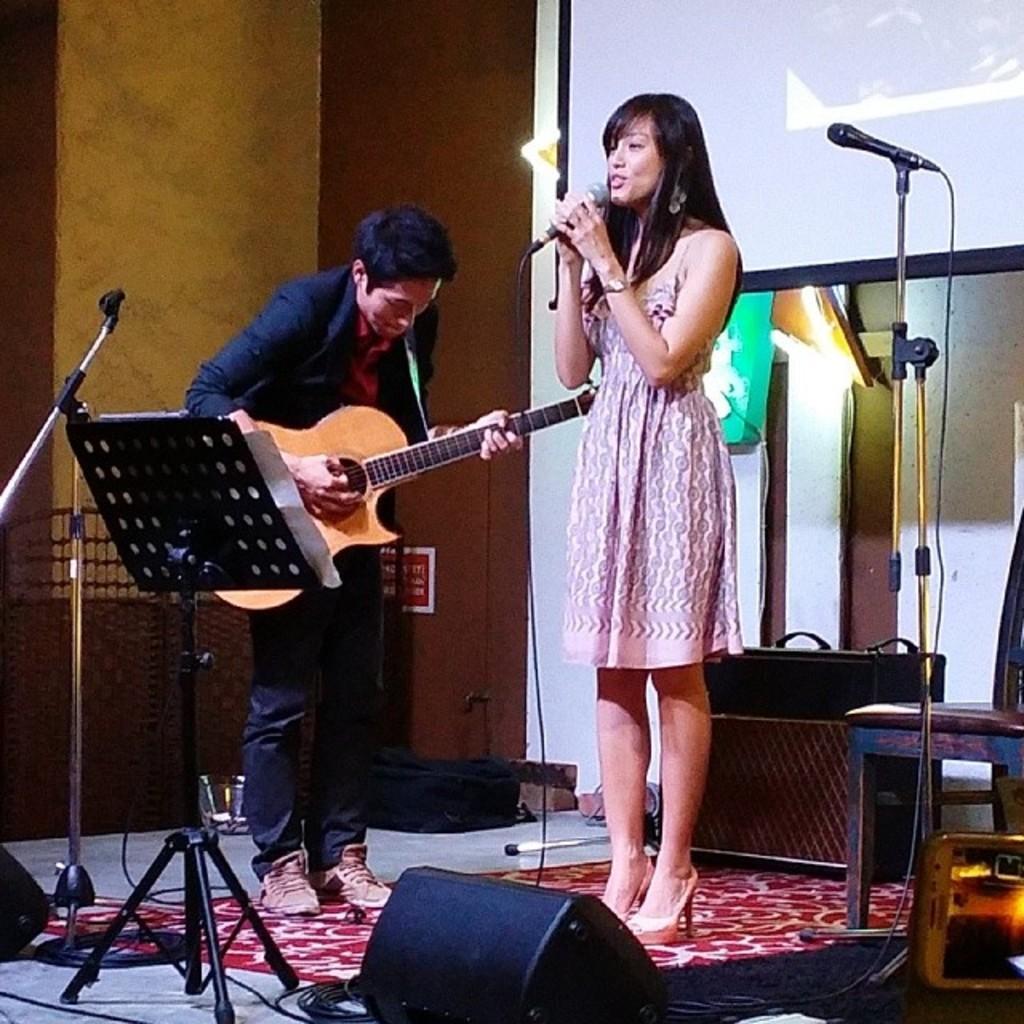Please provide a concise description of this image. there are 2 people in this image. the person at the left is playing guitar and the person at right is holding microphone. behind them there is a projector display. 